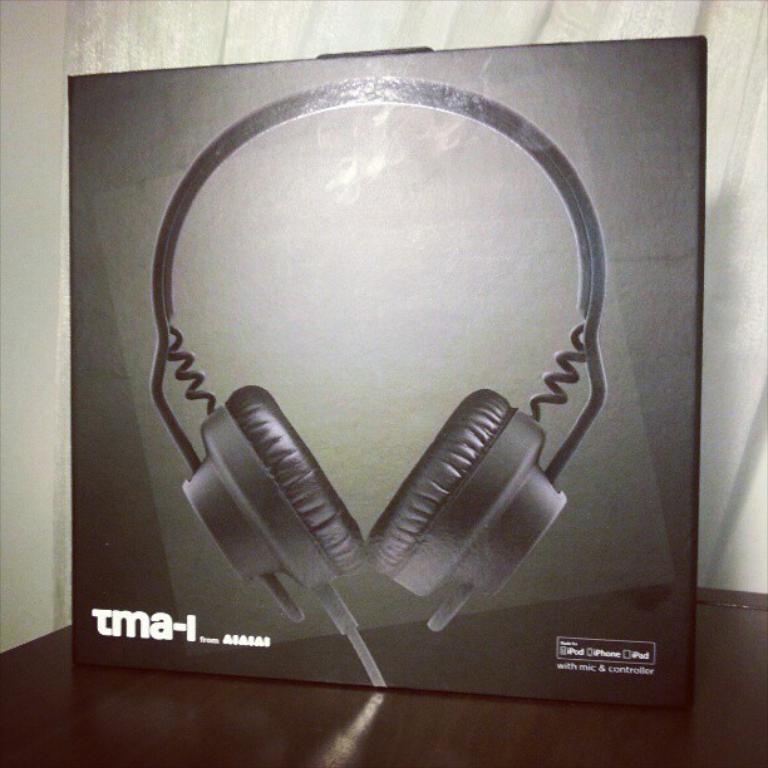What object is located on the table in the image? There is a box on the table in the image. What can be seen behind the box? There is a curtain and a wall behind the box. What is depicted on the box? The box has an image of a headset on it. Are there any words on the box? Yes, there are words on the box. What type of coal is being used to fuel the party in the image? There is no coal or party present in the image; it features a box on a table with a curtain and a wall in the background. 